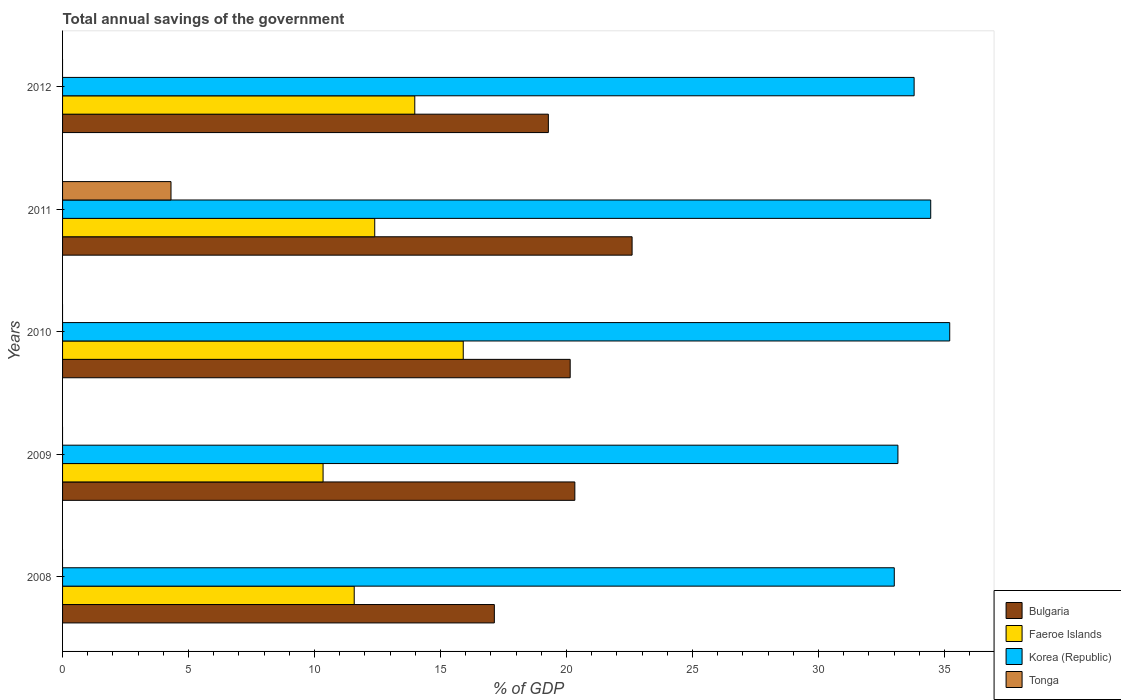How many groups of bars are there?
Your response must be concise. 5. Are the number of bars per tick equal to the number of legend labels?
Give a very brief answer. No. How many bars are there on the 2nd tick from the top?
Your answer should be compact. 4. What is the label of the 1st group of bars from the top?
Keep it short and to the point. 2012. What is the total annual savings of the government in Korea (Republic) in 2008?
Keep it short and to the point. 33.01. Across all years, what is the maximum total annual savings of the government in Korea (Republic)?
Make the answer very short. 35.21. Across all years, what is the minimum total annual savings of the government in Tonga?
Offer a very short reply. 0. What is the total total annual savings of the government in Tonga in the graph?
Your response must be concise. 4.3. What is the difference between the total annual savings of the government in Faeroe Islands in 2010 and that in 2011?
Your answer should be very brief. 3.51. What is the difference between the total annual savings of the government in Faeroe Islands in 2011 and the total annual savings of the government in Tonga in 2008?
Give a very brief answer. 12.39. What is the average total annual savings of the government in Korea (Republic) per year?
Offer a very short reply. 33.92. In the year 2009, what is the difference between the total annual savings of the government in Bulgaria and total annual savings of the government in Korea (Republic)?
Offer a very short reply. -12.82. What is the ratio of the total annual savings of the government in Bulgaria in 2008 to that in 2012?
Give a very brief answer. 0.89. Is the total annual savings of the government in Faeroe Islands in 2011 less than that in 2012?
Your response must be concise. Yes. Is the difference between the total annual savings of the government in Bulgaria in 2009 and 2011 greater than the difference between the total annual savings of the government in Korea (Republic) in 2009 and 2011?
Offer a terse response. No. What is the difference between the highest and the second highest total annual savings of the government in Korea (Republic)?
Offer a terse response. 0.75. What is the difference between the highest and the lowest total annual savings of the government in Faeroe Islands?
Make the answer very short. 5.56. Is the sum of the total annual savings of the government in Bulgaria in 2008 and 2011 greater than the maximum total annual savings of the government in Faeroe Islands across all years?
Make the answer very short. Yes. Is it the case that in every year, the sum of the total annual savings of the government in Tonga and total annual savings of the government in Bulgaria is greater than the sum of total annual savings of the government in Korea (Republic) and total annual savings of the government in Faeroe Islands?
Make the answer very short. No. Is it the case that in every year, the sum of the total annual savings of the government in Faeroe Islands and total annual savings of the government in Korea (Republic) is greater than the total annual savings of the government in Bulgaria?
Offer a terse response. Yes. How many years are there in the graph?
Offer a terse response. 5. Are the values on the major ticks of X-axis written in scientific E-notation?
Make the answer very short. No. Does the graph contain any zero values?
Your response must be concise. Yes. Does the graph contain grids?
Ensure brevity in your answer.  No. Where does the legend appear in the graph?
Your answer should be compact. Bottom right. How are the legend labels stacked?
Your response must be concise. Vertical. What is the title of the graph?
Ensure brevity in your answer.  Total annual savings of the government. Does "Gabon" appear as one of the legend labels in the graph?
Your answer should be very brief. No. What is the label or title of the X-axis?
Make the answer very short. % of GDP. What is the % of GDP in Bulgaria in 2008?
Make the answer very short. 17.14. What is the % of GDP in Faeroe Islands in 2008?
Give a very brief answer. 11.57. What is the % of GDP in Korea (Republic) in 2008?
Your response must be concise. 33.01. What is the % of GDP of Bulgaria in 2009?
Offer a terse response. 20.33. What is the % of GDP of Faeroe Islands in 2009?
Make the answer very short. 10.34. What is the % of GDP in Korea (Republic) in 2009?
Ensure brevity in your answer.  33.15. What is the % of GDP of Tonga in 2009?
Your answer should be compact. 0. What is the % of GDP in Bulgaria in 2010?
Offer a terse response. 20.15. What is the % of GDP of Faeroe Islands in 2010?
Provide a short and direct response. 15.9. What is the % of GDP of Korea (Republic) in 2010?
Provide a succinct answer. 35.21. What is the % of GDP of Bulgaria in 2011?
Keep it short and to the point. 22.6. What is the % of GDP of Faeroe Islands in 2011?
Your answer should be very brief. 12.39. What is the % of GDP in Korea (Republic) in 2011?
Your answer should be compact. 34.45. What is the % of GDP of Tonga in 2011?
Offer a very short reply. 4.3. What is the % of GDP in Bulgaria in 2012?
Offer a very short reply. 19.28. What is the % of GDP of Faeroe Islands in 2012?
Keep it short and to the point. 13.98. What is the % of GDP in Korea (Republic) in 2012?
Your response must be concise. 33.8. What is the % of GDP of Tonga in 2012?
Your answer should be compact. 0. Across all years, what is the maximum % of GDP in Bulgaria?
Keep it short and to the point. 22.6. Across all years, what is the maximum % of GDP in Faeroe Islands?
Your answer should be very brief. 15.9. Across all years, what is the maximum % of GDP of Korea (Republic)?
Offer a very short reply. 35.21. Across all years, what is the maximum % of GDP in Tonga?
Your answer should be compact. 4.3. Across all years, what is the minimum % of GDP of Bulgaria?
Provide a short and direct response. 17.14. Across all years, what is the minimum % of GDP in Faeroe Islands?
Provide a succinct answer. 10.34. Across all years, what is the minimum % of GDP of Korea (Republic)?
Provide a succinct answer. 33.01. Across all years, what is the minimum % of GDP in Tonga?
Your response must be concise. 0. What is the total % of GDP in Bulgaria in the graph?
Keep it short and to the point. 99.49. What is the total % of GDP in Faeroe Islands in the graph?
Your response must be concise. 64.18. What is the total % of GDP in Korea (Republic) in the graph?
Provide a short and direct response. 169.62. What is the total % of GDP of Tonga in the graph?
Provide a short and direct response. 4.3. What is the difference between the % of GDP in Bulgaria in 2008 and that in 2009?
Your answer should be very brief. -3.19. What is the difference between the % of GDP in Faeroe Islands in 2008 and that in 2009?
Make the answer very short. 1.24. What is the difference between the % of GDP of Korea (Republic) in 2008 and that in 2009?
Provide a succinct answer. -0.14. What is the difference between the % of GDP in Bulgaria in 2008 and that in 2010?
Your response must be concise. -3.01. What is the difference between the % of GDP in Faeroe Islands in 2008 and that in 2010?
Keep it short and to the point. -4.33. What is the difference between the % of GDP in Korea (Republic) in 2008 and that in 2010?
Offer a very short reply. -2.2. What is the difference between the % of GDP in Bulgaria in 2008 and that in 2011?
Offer a very short reply. -5.47. What is the difference between the % of GDP of Faeroe Islands in 2008 and that in 2011?
Provide a short and direct response. -0.81. What is the difference between the % of GDP of Korea (Republic) in 2008 and that in 2011?
Keep it short and to the point. -1.45. What is the difference between the % of GDP in Bulgaria in 2008 and that in 2012?
Provide a short and direct response. -2.14. What is the difference between the % of GDP of Faeroe Islands in 2008 and that in 2012?
Give a very brief answer. -2.4. What is the difference between the % of GDP of Korea (Republic) in 2008 and that in 2012?
Keep it short and to the point. -0.79. What is the difference between the % of GDP in Bulgaria in 2009 and that in 2010?
Your response must be concise. 0.18. What is the difference between the % of GDP of Faeroe Islands in 2009 and that in 2010?
Make the answer very short. -5.56. What is the difference between the % of GDP in Korea (Republic) in 2009 and that in 2010?
Keep it short and to the point. -2.06. What is the difference between the % of GDP in Bulgaria in 2009 and that in 2011?
Give a very brief answer. -2.27. What is the difference between the % of GDP in Faeroe Islands in 2009 and that in 2011?
Ensure brevity in your answer.  -2.05. What is the difference between the % of GDP of Korea (Republic) in 2009 and that in 2011?
Your answer should be very brief. -1.3. What is the difference between the % of GDP of Bulgaria in 2009 and that in 2012?
Give a very brief answer. 1.05. What is the difference between the % of GDP of Faeroe Islands in 2009 and that in 2012?
Offer a very short reply. -3.64. What is the difference between the % of GDP in Korea (Republic) in 2009 and that in 2012?
Make the answer very short. -0.64. What is the difference between the % of GDP in Bulgaria in 2010 and that in 2011?
Provide a succinct answer. -2.46. What is the difference between the % of GDP of Faeroe Islands in 2010 and that in 2011?
Your response must be concise. 3.51. What is the difference between the % of GDP of Korea (Republic) in 2010 and that in 2011?
Ensure brevity in your answer.  0.75. What is the difference between the % of GDP of Bulgaria in 2010 and that in 2012?
Offer a terse response. 0.87. What is the difference between the % of GDP of Faeroe Islands in 2010 and that in 2012?
Your response must be concise. 1.92. What is the difference between the % of GDP in Korea (Republic) in 2010 and that in 2012?
Offer a terse response. 1.41. What is the difference between the % of GDP of Bulgaria in 2011 and that in 2012?
Ensure brevity in your answer.  3.32. What is the difference between the % of GDP of Faeroe Islands in 2011 and that in 2012?
Your answer should be very brief. -1.59. What is the difference between the % of GDP of Korea (Republic) in 2011 and that in 2012?
Your response must be concise. 0.66. What is the difference between the % of GDP in Bulgaria in 2008 and the % of GDP in Faeroe Islands in 2009?
Your answer should be compact. 6.8. What is the difference between the % of GDP of Bulgaria in 2008 and the % of GDP of Korea (Republic) in 2009?
Provide a succinct answer. -16.02. What is the difference between the % of GDP of Faeroe Islands in 2008 and the % of GDP of Korea (Republic) in 2009?
Offer a very short reply. -21.58. What is the difference between the % of GDP of Bulgaria in 2008 and the % of GDP of Faeroe Islands in 2010?
Your answer should be compact. 1.23. What is the difference between the % of GDP of Bulgaria in 2008 and the % of GDP of Korea (Republic) in 2010?
Your answer should be very brief. -18.07. What is the difference between the % of GDP of Faeroe Islands in 2008 and the % of GDP of Korea (Republic) in 2010?
Keep it short and to the point. -23.63. What is the difference between the % of GDP of Bulgaria in 2008 and the % of GDP of Faeroe Islands in 2011?
Give a very brief answer. 4.75. What is the difference between the % of GDP in Bulgaria in 2008 and the % of GDP in Korea (Republic) in 2011?
Your answer should be very brief. -17.32. What is the difference between the % of GDP in Bulgaria in 2008 and the % of GDP in Tonga in 2011?
Your response must be concise. 12.83. What is the difference between the % of GDP of Faeroe Islands in 2008 and the % of GDP of Korea (Republic) in 2011?
Keep it short and to the point. -22.88. What is the difference between the % of GDP in Faeroe Islands in 2008 and the % of GDP in Tonga in 2011?
Provide a succinct answer. 7.27. What is the difference between the % of GDP of Korea (Republic) in 2008 and the % of GDP of Tonga in 2011?
Provide a short and direct response. 28.7. What is the difference between the % of GDP of Bulgaria in 2008 and the % of GDP of Faeroe Islands in 2012?
Keep it short and to the point. 3.16. What is the difference between the % of GDP in Bulgaria in 2008 and the % of GDP in Korea (Republic) in 2012?
Offer a terse response. -16.66. What is the difference between the % of GDP of Faeroe Islands in 2008 and the % of GDP of Korea (Republic) in 2012?
Offer a very short reply. -22.22. What is the difference between the % of GDP in Bulgaria in 2009 and the % of GDP in Faeroe Islands in 2010?
Provide a succinct answer. 4.43. What is the difference between the % of GDP in Bulgaria in 2009 and the % of GDP in Korea (Republic) in 2010?
Offer a very short reply. -14.88. What is the difference between the % of GDP in Faeroe Islands in 2009 and the % of GDP in Korea (Republic) in 2010?
Provide a succinct answer. -24.87. What is the difference between the % of GDP of Bulgaria in 2009 and the % of GDP of Faeroe Islands in 2011?
Ensure brevity in your answer.  7.94. What is the difference between the % of GDP of Bulgaria in 2009 and the % of GDP of Korea (Republic) in 2011?
Provide a succinct answer. -14.12. What is the difference between the % of GDP of Bulgaria in 2009 and the % of GDP of Tonga in 2011?
Give a very brief answer. 16.03. What is the difference between the % of GDP in Faeroe Islands in 2009 and the % of GDP in Korea (Republic) in 2011?
Make the answer very short. -24.11. What is the difference between the % of GDP of Faeroe Islands in 2009 and the % of GDP of Tonga in 2011?
Offer a very short reply. 6.04. What is the difference between the % of GDP of Korea (Republic) in 2009 and the % of GDP of Tonga in 2011?
Provide a succinct answer. 28.85. What is the difference between the % of GDP of Bulgaria in 2009 and the % of GDP of Faeroe Islands in 2012?
Your answer should be very brief. 6.35. What is the difference between the % of GDP in Bulgaria in 2009 and the % of GDP in Korea (Republic) in 2012?
Ensure brevity in your answer.  -13.47. What is the difference between the % of GDP in Faeroe Islands in 2009 and the % of GDP in Korea (Republic) in 2012?
Your response must be concise. -23.46. What is the difference between the % of GDP of Bulgaria in 2010 and the % of GDP of Faeroe Islands in 2011?
Your answer should be very brief. 7.76. What is the difference between the % of GDP in Bulgaria in 2010 and the % of GDP in Korea (Republic) in 2011?
Keep it short and to the point. -14.31. What is the difference between the % of GDP in Bulgaria in 2010 and the % of GDP in Tonga in 2011?
Keep it short and to the point. 15.84. What is the difference between the % of GDP of Faeroe Islands in 2010 and the % of GDP of Korea (Republic) in 2011?
Your response must be concise. -18.55. What is the difference between the % of GDP in Faeroe Islands in 2010 and the % of GDP in Tonga in 2011?
Offer a terse response. 11.6. What is the difference between the % of GDP of Korea (Republic) in 2010 and the % of GDP of Tonga in 2011?
Your answer should be very brief. 30.9. What is the difference between the % of GDP in Bulgaria in 2010 and the % of GDP in Faeroe Islands in 2012?
Your response must be concise. 6.17. What is the difference between the % of GDP of Bulgaria in 2010 and the % of GDP of Korea (Republic) in 2012?
Provide a succinct answer. -13.65. What is the difference between the % of GDP in Faeroe Islands in 2010 and the % of GDP in Korea (Republic) in 2012?
Ensure brevity in your answer.  -17.89. What is the difference between the % of GDP in Bulgaria in 2011 and the % of GDP in Faeroe Islands in 2012?
Ensure brevity in your answer.  8.62. What is the difference between the % of GDP of Bulgaria in 2011 and the % of GDP of Korea (Republic) in 2012?
Keep it short and to the point. -11.19. What is the difference between the % of GDP of Faeroe Islands in 2011 and the % of GDP of Korea (Republic) in 2012?
Keep it short and to the point. -21.41. What is the average % of GDP in Bulgaria per year?
Keep it short and to the point. 19.9. What is the average % of GDP in Faeroe Islands per year?
Make the answer very short. 12.84. What is the average % of GDP in Korea (Republic) per year?
Your response must be concise. 33.92. What is the average % of GDP in Tonga per year?
Offer a very short reply. 0.86. In the year 2008, what is the difference between the % of GDP of Bulgaria and % of GDP of Faeroe Islands?
Provide a short and direct response. 5.56. In the year 2008, what is the difference between the % of GDP in Bulgaria and % of GDP in Korea (Republic)?
Your answer should be compact. -15.87. In the year 2008, what is the difference between the % of GDP of Faeroe Islands and % of GDP of Korea (Republic)?
Make the answer very short. -21.43. In the year 2009, what is the difference between the % of GDP in Bulgaria and % of GDP in Faeroe Islands?
Make the answer very short. 9.99. In the year 2009, what is the difference between the % of GDP of Bulgaria and % of GDP of Korea (Republic)?
Keep it short and to the point. -12.82. In the year 2009, what is the difference between the % of GDP in Faeroe Islands and % of GDP in Korea (Republic)?
Your response must be concise. -22.81. In the year 2010, what is the difference between the % of GDP in Bulgaria and % of GDP in Faeroe Islands?
Provide a short and direct response. 4.24. In the year 2010, what is the difference between the % of GDP in Bulgaria and % of GDP in Korea (Republic)?
Your answer should be very brief. -15.06. In the year 2010, what is the difference between the % of GDP in Faeroe Islands and % of GDP in Korea (Republic)?
Offer a very short reply. -19.31. In the year 2011, what is the difference between the % of GDP of Bulgaria and % of GDP of Faeroe Islands?
Provide a short and direct response. 10.21. In the year 2011, what is the difference between the % of GDP in Bulgaria and % of GDP in Korea (Republic)?
Provide a short and direct response. -11.85. In the year 2011, what is the difference between the % of GDP in Bulgaria and % of GDP in Tonga?
Provide a short and direct response. 18.3. In the year 2011, what is the difference between the % of GDP in Faeroe Islands and % of GDP in Korea (Republic)?
Give a very brief answer. -22.07. In the year 2011, what is the difference between the % of GDP in Faeroe Islands and % of GDP in Tonga?
Keep it short and to the point. 8.09. In the year 2011, what is the difference between the % of GDP in Korea (Republic) and % of GDP in Tonga?
Your answer should be compact. 30.15. In the year 2012, what is the difference between the % of GDP of Bulgaria and % of GDP of Faeroe Islands?
Your answer should be very brief. 5.3. In the year 2012, what is the difference between the % of GDP of Bulgaria and % of GDP of Korea (Republic)?
Your answer should be very brief. -14.52. In the year 2012, what is the difference between the % of GDP of Faeroe Islands and % of GDP of Korea (Republic)?
Give a very brief answer. -19.82. What is the ratio of the % of GDP of Bulgaria in 2008 to that in 2009?
Your response must be concise. 0.84. What is the ratio of the % of GDP in Faeroe Islands in 2008 to that in 2009?
Provide a succinct answer. 1.12. What is the ratio of the % of GDP in Bulgaria in 2008 to that in 2010?
Make the answer very short. 0.85. What is the ratio of the % of GDP of Faeroe Islands in 2008 to that in 2010?
Ensure brevity in your answer.  0.73. What is the ratio of the % of GDP of Bulgaria in 2008 to that in 2011?
Your response must be concise. 0.76. What is the ratio of the % of GDP in Faeroe Islands in 2008 to that in 2011?
Make the answer very short. 0.93. What is the ratio of the % of GDP of Korea (Republic) in 2008 to that in 2011?
Offer a terse response. 0.96. What is the ratio of the % of GDP of Bulgaria in 2008 to that in 2012?
Your response must be concise. 0.89. What is the ratio of the % of GDP of Faeroe Islands in 2008 to that in 2012?
Your response must be concise. 0.83. What is the ratio of the % of GDP in Korea (Republic) in 2008 to that in 2012?
Your response must be concise. 0.98. What is the ratio of the % of GDP in Bulgaria in 2009 to that in 2010?
Offer a terse response. 1.01. What is the ratio of the % of GDP in Faeroe Islands in 2009 to that in 2010?
Give a very brief answer. 0.65. What is the ratio of the % of GDP in Korea (Republic) in 2009 to that in 2010?
Offer a very short reply. 0.94. What is the ratio of the % of GDP of Bulgaria in 2009 to that in 2011?
Ensure brevity in your answer.  0.9. What is the ratio of the % of GDP of Faeroe Islands in 2009 to that in 2011?
Provide a short and direct response. 0.83. What is the ratio of the % of GDP of Korea (Republic) in 2009 to that in 2011?
Provide a short and direct response. 0.96. What is the ratio of the % of GDP in Bulgaria in 2009 to that in 2012?
Offer a terse response. 1.05. What is the ratio of the % of GDP of Faeroe Islands in 2009 to that in 2012?
Your answer should be compact. 0.74. What is the ratio of the % of GDP of Korea (Republic) in 2009 to that in 2012?
Keep it short and to the point. 0.98. What is the ratio of the % of GDP of Bulgaria in 2010 to that in 2011?
Offer a terse response. 0.89. What is the ratio of the % of GDP of Faeroe Islands in 2010 to that in 2011?
Offer a very short reply. 1.28. What is the ratio of the % of GDP in Korea (Republic) in 2010 to that in 2011?
Offer a very short reply. 1.02. What is the ratio of the % of GDP in Bulgaria in 2010 to that in 2012?
Offer a very short reply. 1.04. What is the ratio of the % of GDP in Faeroe Islands in 2010 to that in 2012?
Make the answer very short. 1.14. What is the ratio of the % of GDP in Korea (Republic) in 2010 to that in 2012?
Your response must be concise. 1.04. What is the ratio of the % of GDP in Bulgaria in 2011 to that in 2012?
Offer a very short reply. 1.17. What is the ratio of the % of GDP of Faeroe Islands in 2011 to that in 2012?
Your answer should be compact. 0.89. What is the ratio of the % of GDP of Korea (Republic) in 2011 to that in 2012?
Ensure brevity in your answer.  1.02. What is the difference between the highest and the second highest % of GDP in Bulgaria?
Keep it short and to the point. 2.27. What is the difference between the highest and the second highest % of GDP of Faeroe Islands?
Your answer should be compact. 1.92. What is the difference between the highest and the second highest % of GDP in Korea (Republic)?
Your response must be concise. 0.75. What is the difference between the highest and the lowest % of GDP of Bulgaria?
Provide a succinct answer. 5.47. What is the difference between the highest and the lowest % of GDP of Faeroe Islands?
Your answer should be very brief. 5.56. What is the difference between the highest and the lowest % of GDP in Tonga?
Your answer should be compact. 4.3. 